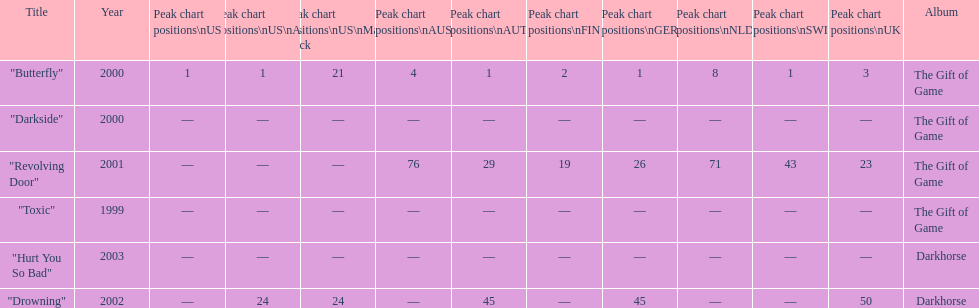By how many chart positions higher did "revolving door" peak in the uk compared to the peak position of "drowning" in the uk? 27. 